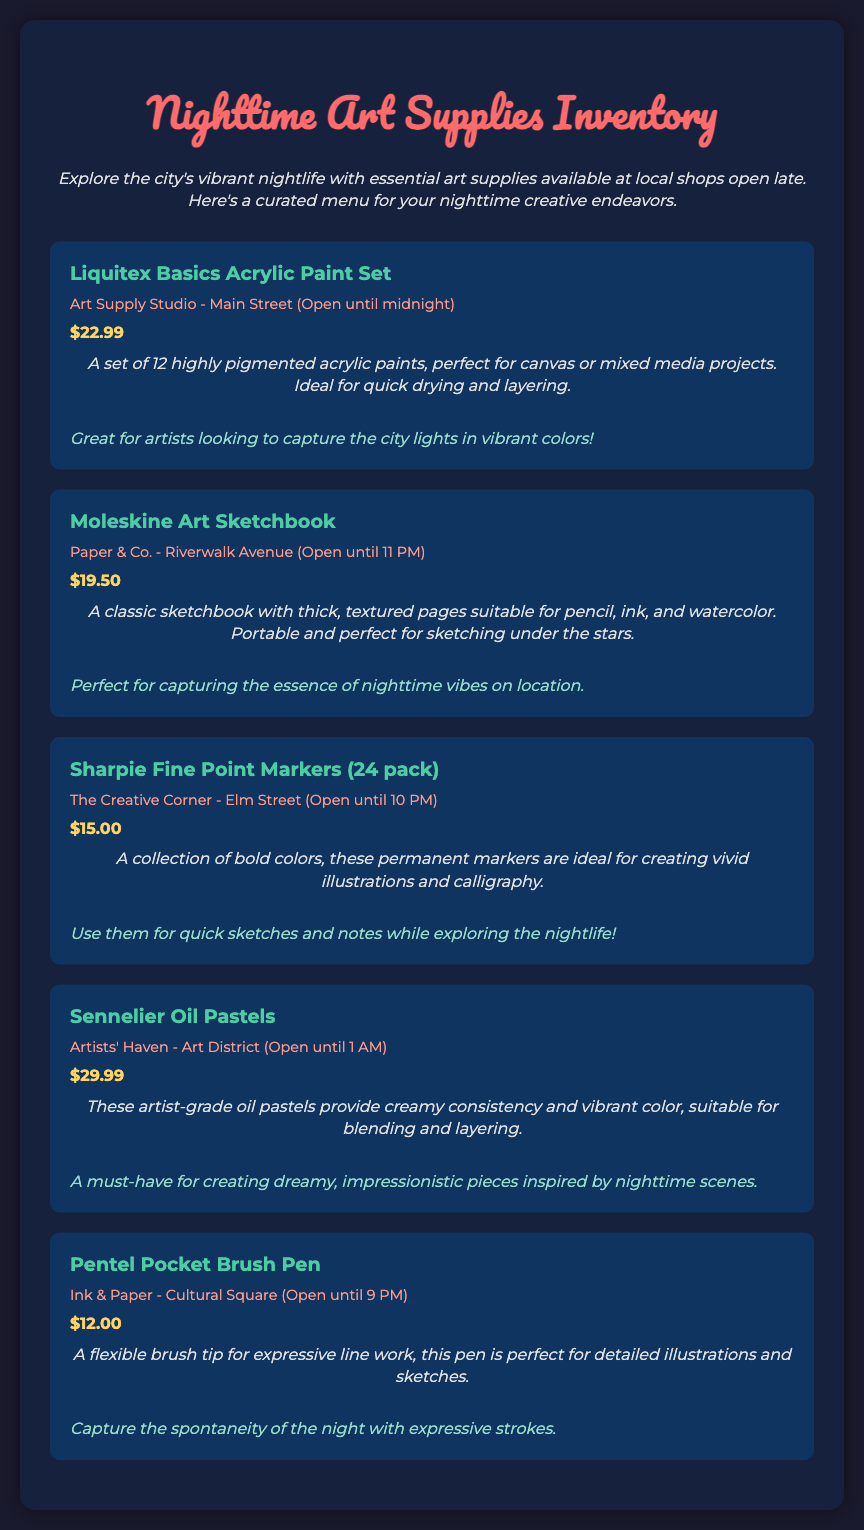What is the price of the Liquitex Basics Acrylic Paint Set? The price is listed under the supply item and is $22.99.
Answer: $22.99 Which shop has the Moleskine Art Sketchbook? The shop information mentions that it is available at Paper & Co.
Answer: Paper & Co What time does The Creative Corner close? The closing time is provided in the shop information for The Creative Corner, which is until 10 PM.
Answer: 10 PM How many colors are in the Sharpie Fine Point Markers pack? The number of colors is indicated in the product name as a pack of 24.
Answer: 24 What is the unique selling point of the Sennelier Oil Pastels? The description highlights that they provide creamy consistency and vibrant color, suitable for blending and layering.
Answer: Creamy consistency and vibrant color Which supply item is recommended for capturing the city lights? The recommendation for the Liquitex Basics Acrylic Paint Set suggests it is ideal for capturing city lights.
Answer: Liquitex Basics Acrylic Paint Set What type of pages does the Moleskine Art Sketchbook have? The description specifies that it has thick, textured pages suitable for various mediums.
Answer: Thick, textured pages Which supply item is best for detailed illustrations? The recommendation for the Pentel Pocket Brush Pen suggests it is best for detailed illustrations and sketches.
Answer: Pentel Pocket Brush Pen What type of art creation are Sharpie Fine Point Markers ideal for? The description states they are ideal for creating vivid illustrations and calligraphy.
Answer: Vivid illustrations and calligraphy 